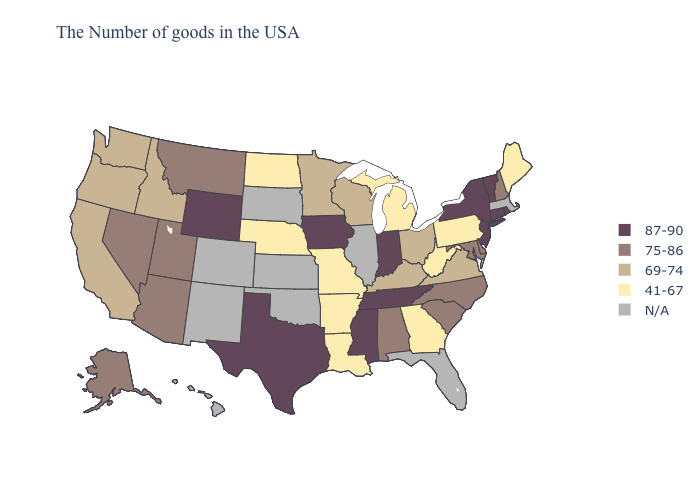Among the states that border Tennessee , does Mississippi have the highest value?
Write a very short answer. Yes. Name the states that have a value in the range 41-67?
Concise answer only. Maine, Pennsylvania, West Virginia, Georgia, Michigan, Louisiana, Missouri, Arkansas, Nebraska, North Dakota. What is the lowest value in states that border Iowa?
Give a very brief answer. 41-67. Does North Dakota have the highest value in the MidWest?
Give a very brief answer. No. What is the value of Maryland?
Short answer required. 75-86. Does New Jersey have the highest value in the Northeast?
Short answer required. Yes. Which states have the lowest value in the USA?
Answer briefly. Maine, Pennsylvania, West Virginia, Georgia, Michigan, Louisiana, Missouri, Arkansas, Nebraska, North Dakota. Which states have the lowest value in the West?
Quick response, please. Idaho, California, Washington, Oregon. What is the value of New Jersey?
Give a very brief answer. 87-90. What is the lowest value in the USA?
Write a very short answer. 41-67. What is the lowest value in the USA?
Keep it brief. 41-67. Does Rhode Island have the highest value in the USA?
Write a very short answer. Yes. Does Wyoming have the highest value in the USA?
Keep it brief. Yes. Among the states that border Illinois , which have the highest value?
Short answer required. Indiana, Iowa. 